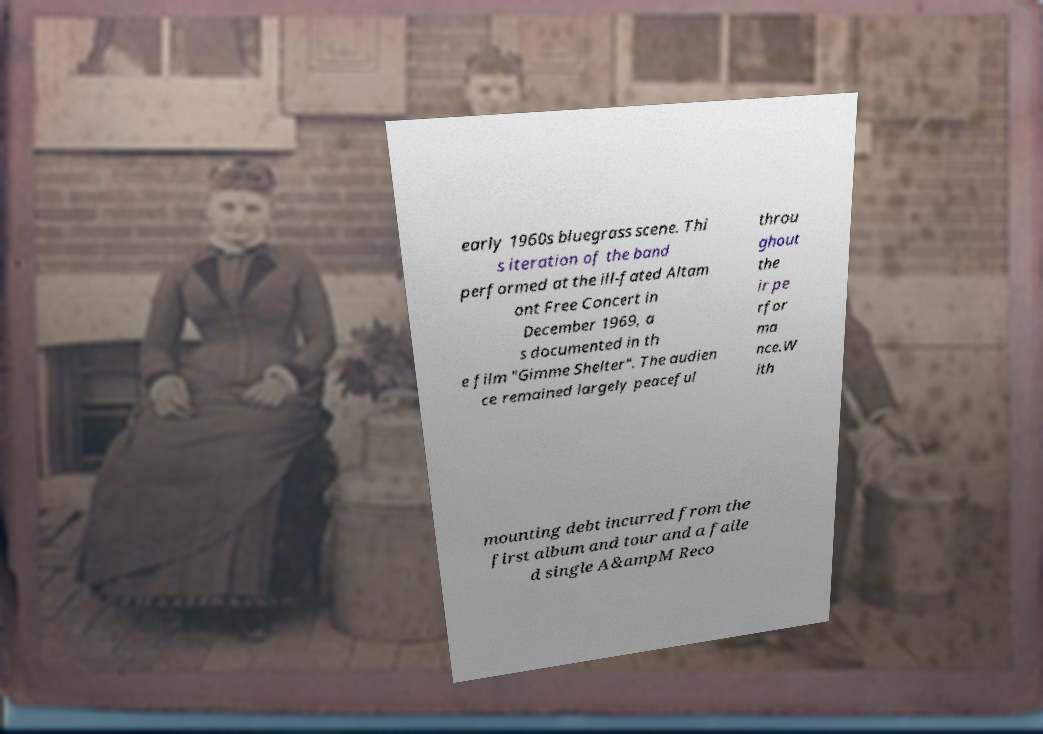There's text embedded in this image that I need extracted. Can you transcribe it verbatim? early 1960s bluegrass scene. Thi s iteration of the band performed at the ill-fated Altam ont Free Concert in December 1969, a s documented in th e film "Gimme Shelter". The audien ce remained largely peaceful throu ghout the ir pe rfor ma nce.W ith mounting debt incurred from the first album and tour and a faile d single A&ampM Reco 